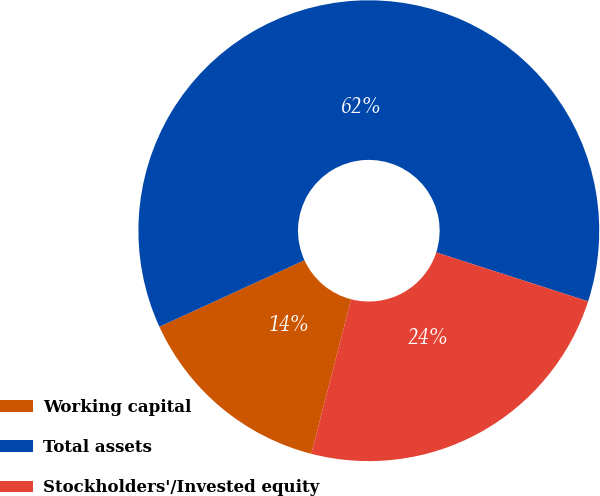<chart> <loc_0><loc_0><loc_500><loc_500><pie_chart><fcel>Working capital<fcel>Total assets<fcel>Stockholders'/Invested equity<nl><fcel>14.14%<fcel>61.8%<fcel>24.06%<nl></chart> 